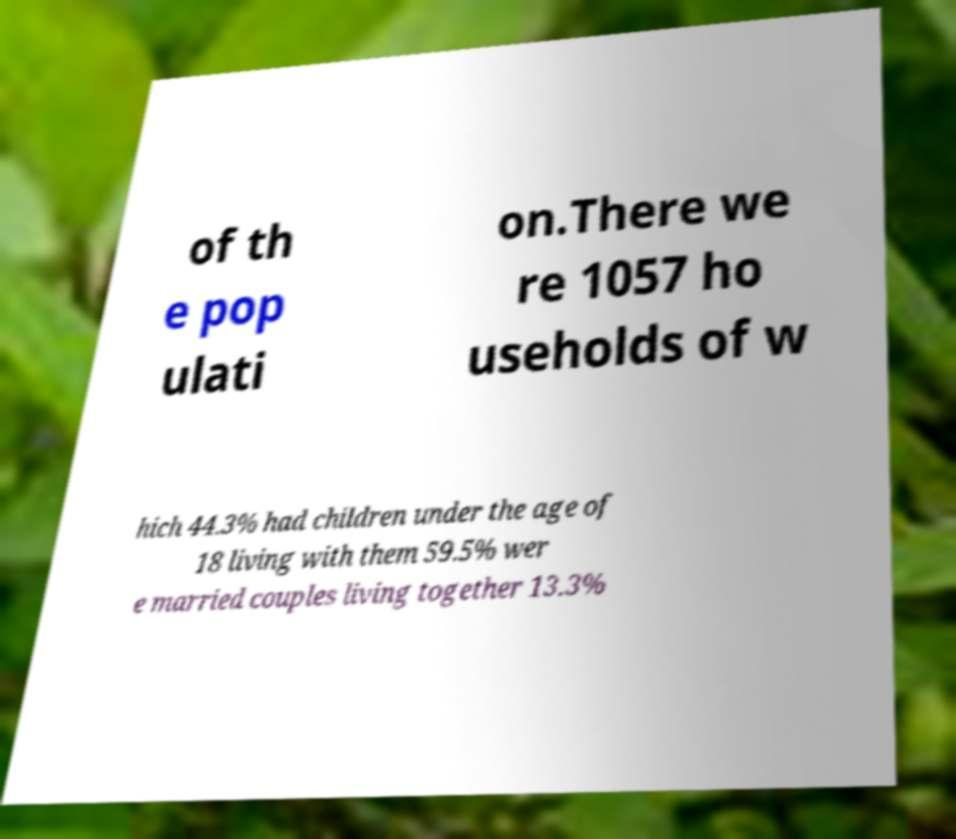For documentation purposes, I need the text within this image transcribed. Could you provide that? of th e pop ulati on.There we re 1057 ho useholds of w hich 44.3% had children under the age of 18 living with them 59.5% wer e married couples living together 13.3% 